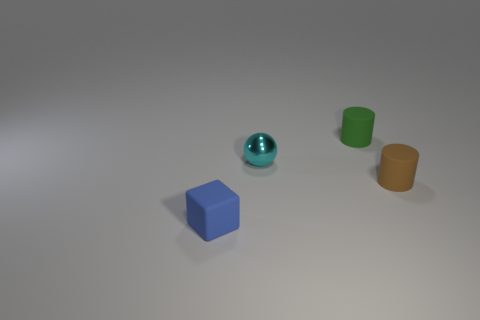Are there any green shiny things of the same size as the blue matte block?
Your answer should be compact. No. There is a small rubber object in front of the tiny brown matte cylinder; what number of cyan metallic spheres are right of it?
Provide a succinct answer. 1. What material is the cyan ball?
Your answer should be very brief. Metal. What number of matte cylinders are behind the tiny brown cylinder?
Make the answer very short. 1. Do the tiny cube and the tiny metallic thing have the same color?
Provide a short and direct response. No. Are there more tiny cyan metallic balls than tiny rubber objects?
Ensure brevity in your answer.  No. Is the cylinder that is behind the cyan shiny thing made of the same material as the sphere left of the green rubber object?
Provide a succinct answer. No. There is a brown rubber object that is the same size as the matte block; what is its shape?
Offer a very short reply. Cylinder. Are there fewer big yellow matte cylinders than cyan metal spheres?
Provide a short and direct response. Yes. There is a small blue rubber block in front of the cyan ball; are there any small brown matte cylinders behind it?
Keep it short and to the point. Yes. 